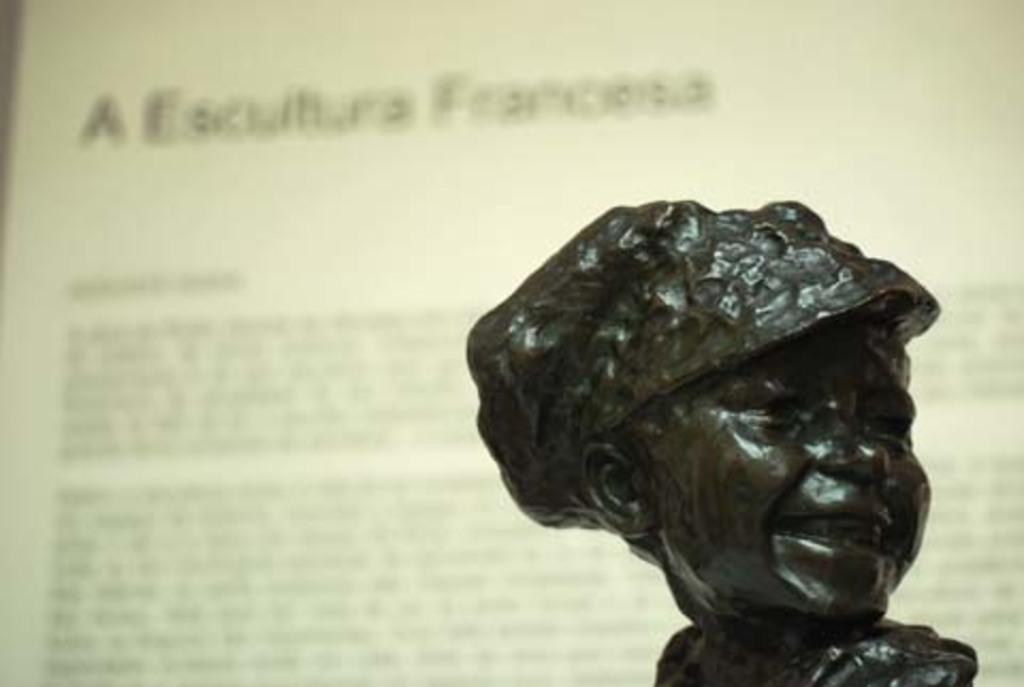What is the main subject of the image? There is a statue in the image. What can you tell about the statue's appearance? The statue is black in color. What else can be seen in the image besides the statue? There is text visible in the background of the image. How would you describe the text in the image? The text appears blurry. How does the shoe compare to the statue in the image? There is no shoe present in the image, so it cannot be compared to the statue. 